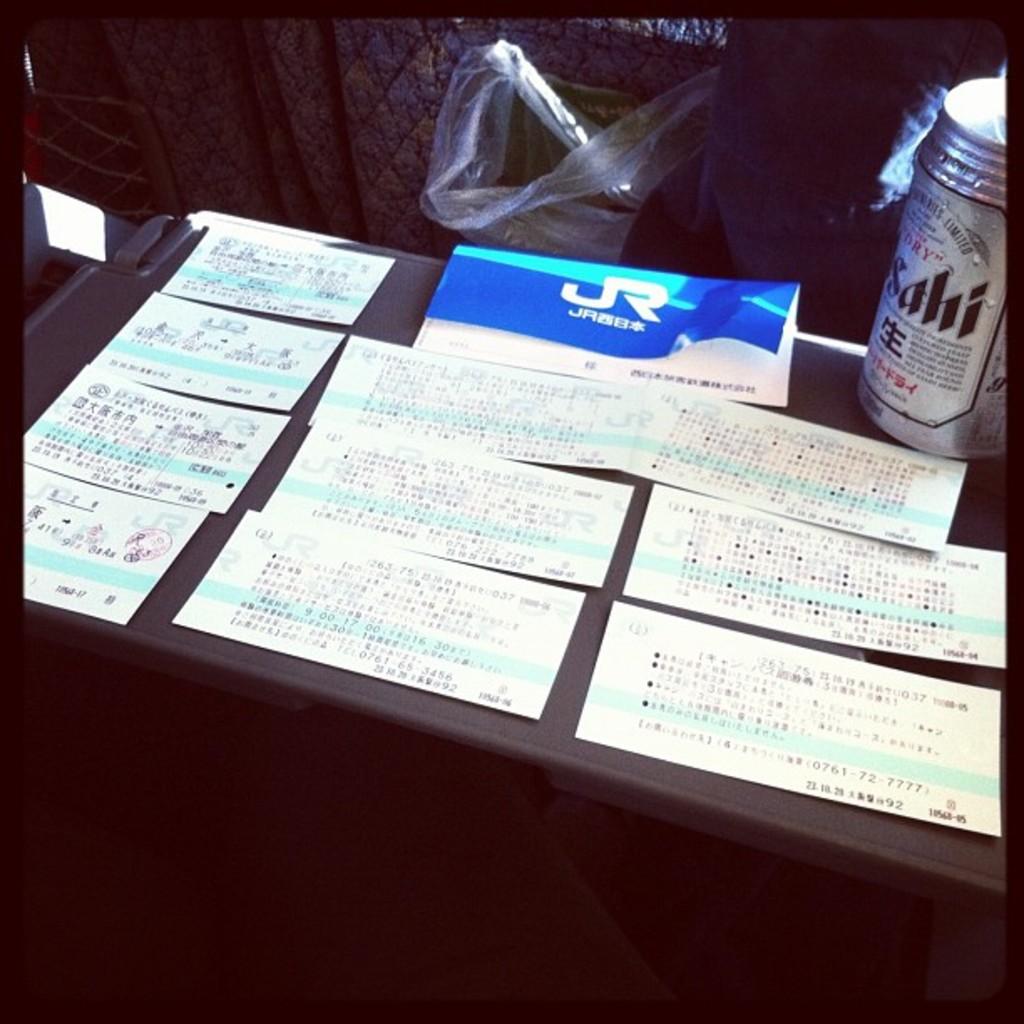What kind of beer is in the can?
Offer a very short reply. Sahi. 